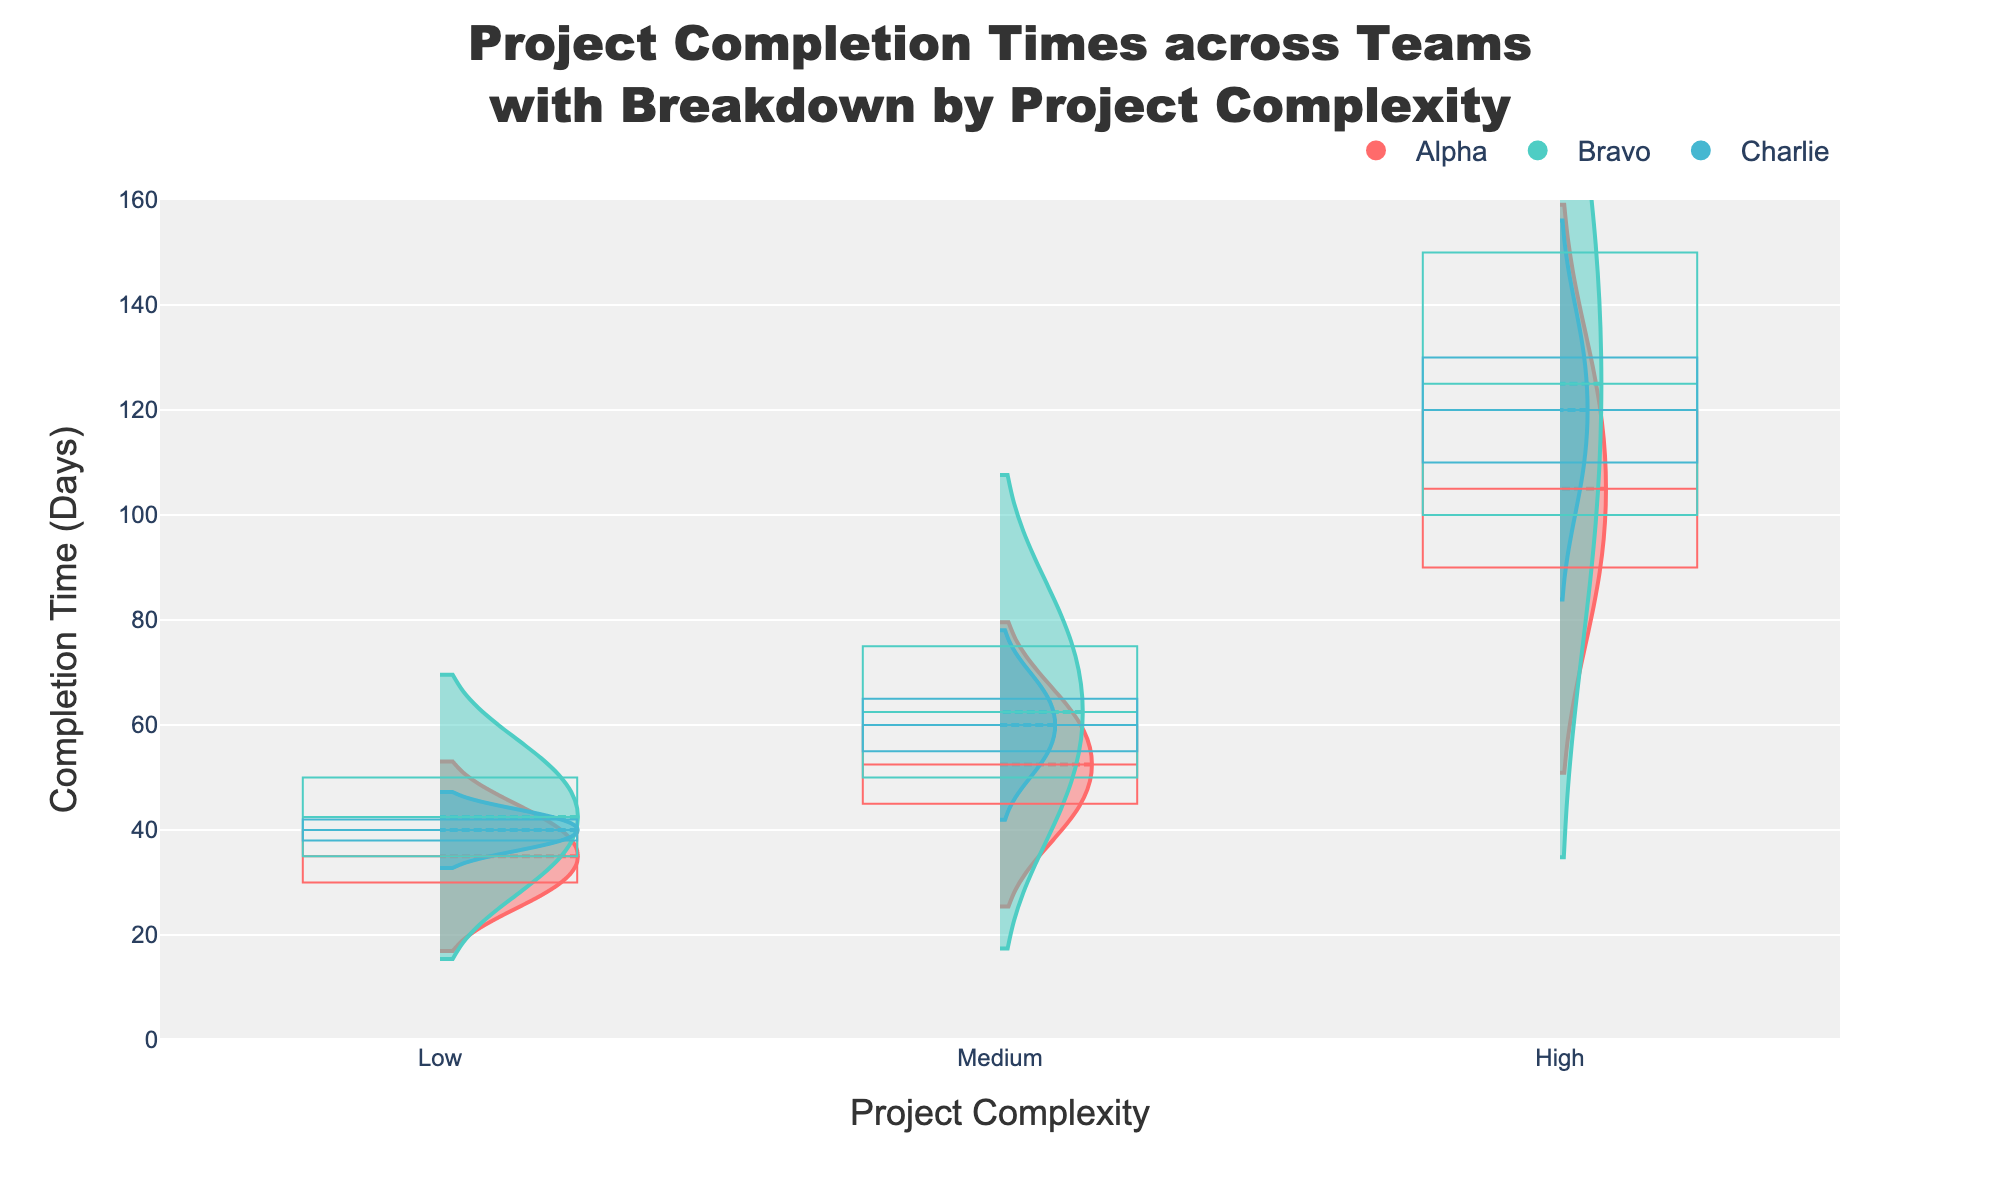What is the title of the figure? The title is typically located at the top of the figure. In this case, the title is specified in the code under the 'update_layout' function.
Answer: Project Completion Times across Teams with Breakdown by Project Complexity What are labels for the x-axis and y-axis? Axis labels are usually next to the axes. Here, they are defined in the 'update_layout' function.
Answer: Project Complexity (x-axis), Completion Time (Days) (y-axis) Which team has the highest completion time for high complexity projects? Looking at the Violin and Box Plots, find the team with the highest y-value under the 'High' category. The highest value is observed for Team Bravo.
Answer: Bravo Compare the completion times for medium complexity projects between Teams Alpha and Charlie. Check the Box Plots and Violin Charts for medium complexity projects. Team Alpha’s median completion time is 60 days, and Team Charlie’s median is 55 days. Charlie’s completion times appear slightly less on average and have lower variance.
Answer: Charlie has slightly lower completion times What is the range of completion times for Team Alpha on low complexity projects? In the Box Plot and Violin Chart for Team Alpha and low complexity, the smallest value is 30 days, and the largest is 40 days.
Answer: 30 to 40 days Which team has the most consistent (least variable) times for medium complexity projects? Locate the narrowest Box Plot or Violin for medium complexity projects. Team Bravo has a narrow Box Plot indicating low variance.
Answer: Bravo How does the completion time for high complexity projects in Team Charlie compare to Team Alpha? Compare the Violin and Box Plots of high complexity projects for both teams. Team Charlie has a median of 130 days, while Team Alpha has 120 days. This indicates that Team Charlie generally takes longer.
Answer: Team Charlie takes longer Is there a noticeable outlier in the completion times for Team Bravo on any project complexity? A noticeable outlier would be marked outside the whiskers of the Box Plot. No distinct outliers are apparent in any Box Plot for Team Bravo.
Answer: No Which project complexity level has the highest median completion time for Team Alpha? Referring to the Box Plot medians for Team Alpha: high complexity (120 days), medium (60 days), and low (40 days), the high complexity projects have the highest median.
Answer: High 